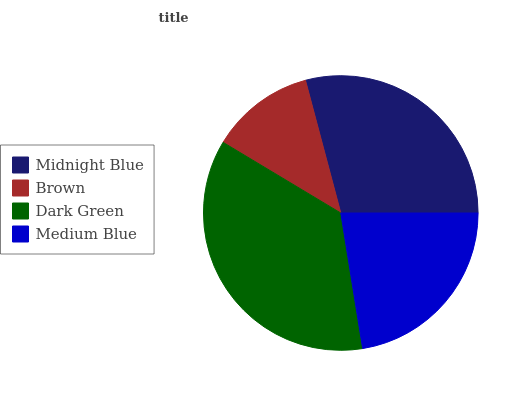Is Brown the minimum?
Answer yes or no. Yes. Is Dark Green the maximum?
Answer yes or no. Yes. Is Dark Green the minimum?
Answer yes or no. No. Is Brown the maximum?
Answer yes or no. No. Is Dark Green greater than Brown?
Answer yes or no. Yes. Is Brown less than Dark Green?
Answer yes or no. Yes. Is Brown greater than Dark Green?
Answer yes or no. No. Is Dark Green less than Brown?
Answer yes or no. No. Is Midnight Blue the high median?
Answer yes or no. Yes. Is Medium Blue the low median?
Answer yes or no. Yes. Is Medium Blue the high median?
Answer yes or no. No. Is Midnight Blue the low median?
Answer yes or no. No. 